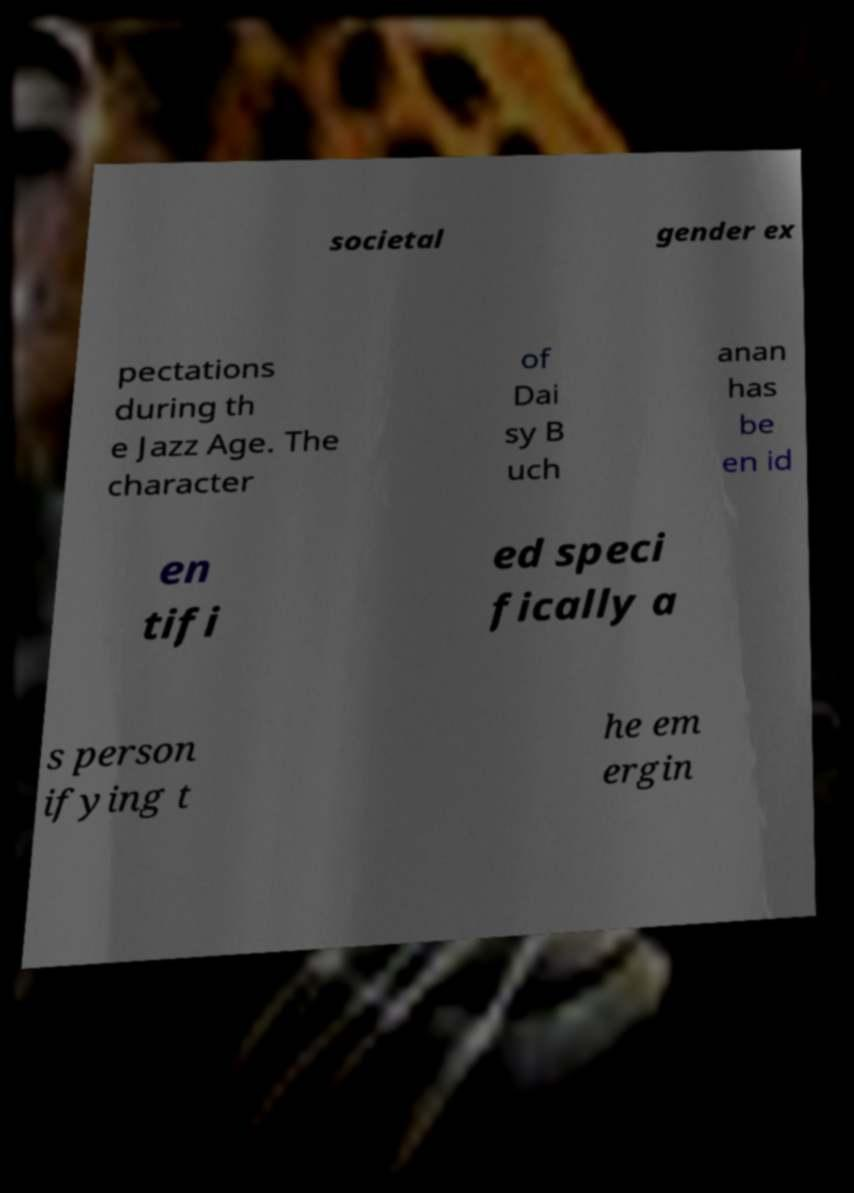Please identify and transcribe the text found in this image. societal gender ex pectations during th e Jazz Age. The character of Dai sy B uch anan has be en id en tifi ed speci fically a s person ifying t he em ergin 